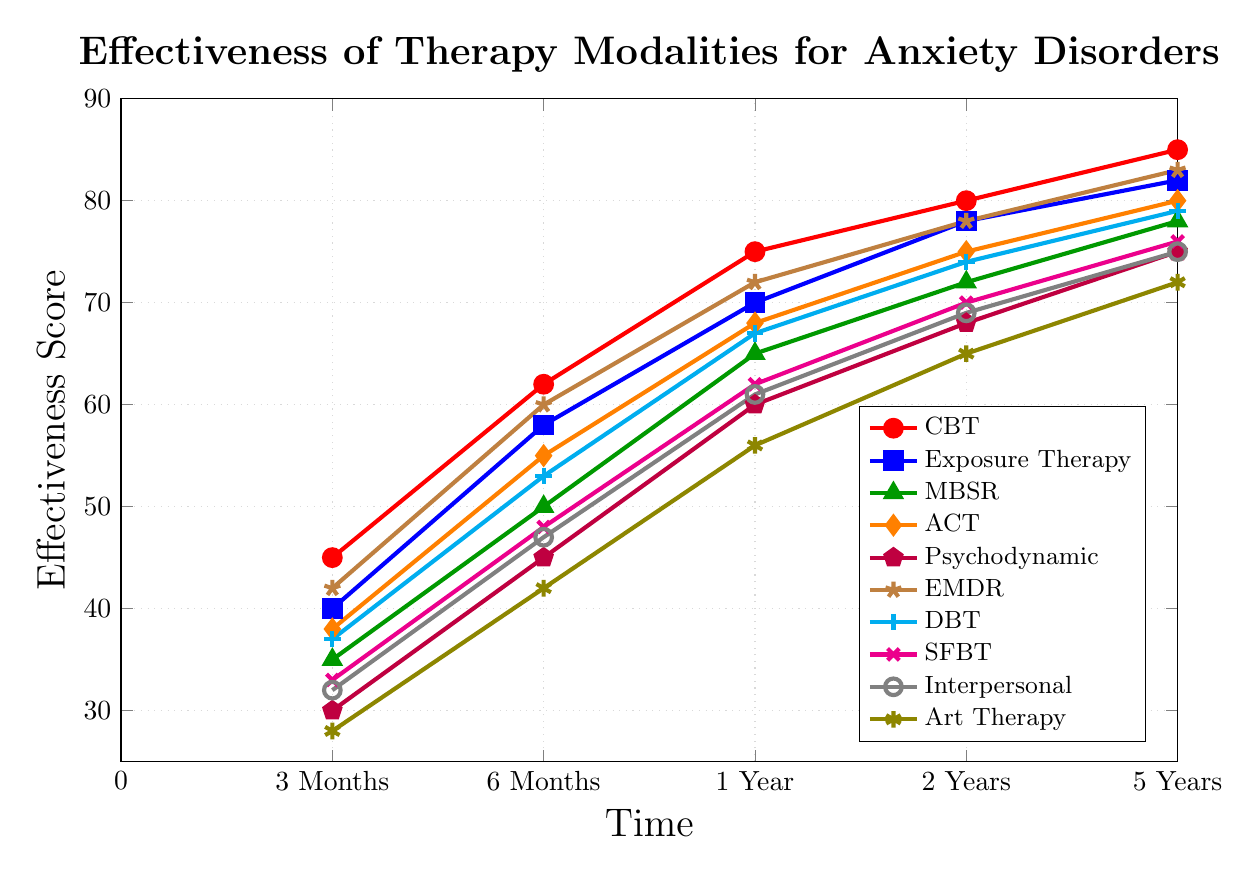What's the most effective therapy modality for treating anxiety disorders at 6 months? By observing the data points at the 6-month mark, Cognitive Behavioral Therapy (CBT) has the highest effectiveness score among the modalities.
Answer: Cognitive Behavioral Therapy (CBT) Which therapy shows the least improvement from 3 months to 5 years? We can calculate the improvement for each therapy by subtracting the 3 months' score from the 5 years' score. Art Therapy shows the least improvement: 72 - 28 = 44.
Answer: Art Therapy What's the average effectiveness score of Dialectical Behavior Therapy (DBT) across all time points? Add all effectiveness scores for DBT and divide by the number of time points: (37 + 53 + 67 + 74 + 79) / 5 = 310 / 5 = 62
Answer: 62 Between Cognitive Behavioral Therapy (CBT) and Exposure Therapy, which shows greater improvement between 1 year and 2 years, and by how much? The improvement for CBT between 1 year and 2 years is 80 - 75 = 5. For Exposure Therapy, it's 78 - 70 = 8. Exposure Therapy shows greater improvement by 8 - 5 = 3.
Answer: Exposure Therapy, 3 What is the median effectiveness score of Psychodynamic Therapy at all the observed time points? The effectiveness scores for Psychodynamic Therapy are 30, 45, 60, 68, 75. The median value is the middle number when arranged in order, which is 60.
Answer: 60 What color represents the effectiveness line for Mindfulness-Based Stress Reduction (MBSR)? The color assigned to Mindfulness-Based Stress Reduction (MBSR) as seen in the legend is green.
Answer: Green How does Acceptance and Commitment Therapy (ACT) effectiveness at 2 years compare to Interpersonal Therapy at the same time point? Look at the effectiveness scores for both therapies at 2 years. ACT has a score of 75, while Interpersonal Therapy has a score of 69. ACT has a higher effectiveness score compared to Interpersonal Therapy at 2 years.
Answer: ACT is higher Which therapy modality exhibits the steepest increase in effectiveness from 3 months to 6 months? By comparing the effectiveness increases from 3 months to 6 months across all modalities: CBT: 62 - 45 = 17, Exposure Therapy: 58 - 40 = 18, MBSR: 50 - 35 = 15, ACT: 55 - 38 = 17, Psychodynamic: 45 - 30 = 15, EMDR: 60 - 42 = 18, DBT: 53 - 37 = 16, SFBT: 48 - 33 = 15, Interpersonal: 47 - 32 = 15, Art Therapy: 42 - 28 = 14. Both Exposure Therapy and EMDR exhibit the steepest increase of 18.
Answer: Exposure Therapy, EMDR 